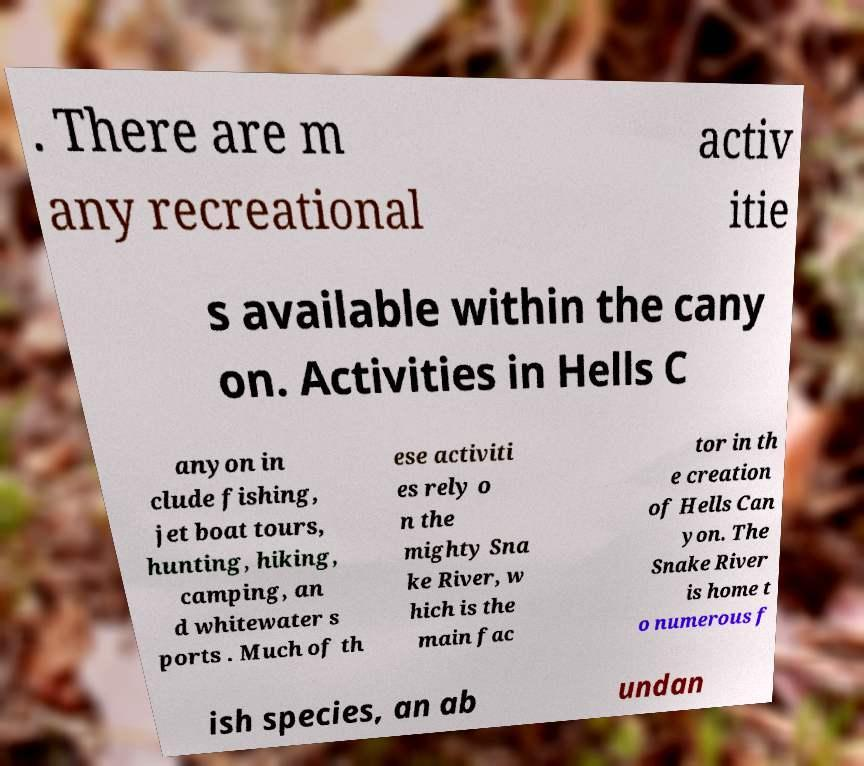Can you read and provide the text displayed in the image?This photo seems to have some interesting text. Can you extract and type it out for me? . There are m any recreational activ itie s available within the cany on. Activities in Hells C anyon in clude fishing, jet boat tours, hunting, hiking, camping, an d whitewater s ports . Much of th ese activiti es rely o n the mighty Sna ke River, w hich is the main fac tor in th e creation of Hells Can yon. The Snake River is home t o numerous f ish species, an ab undan 